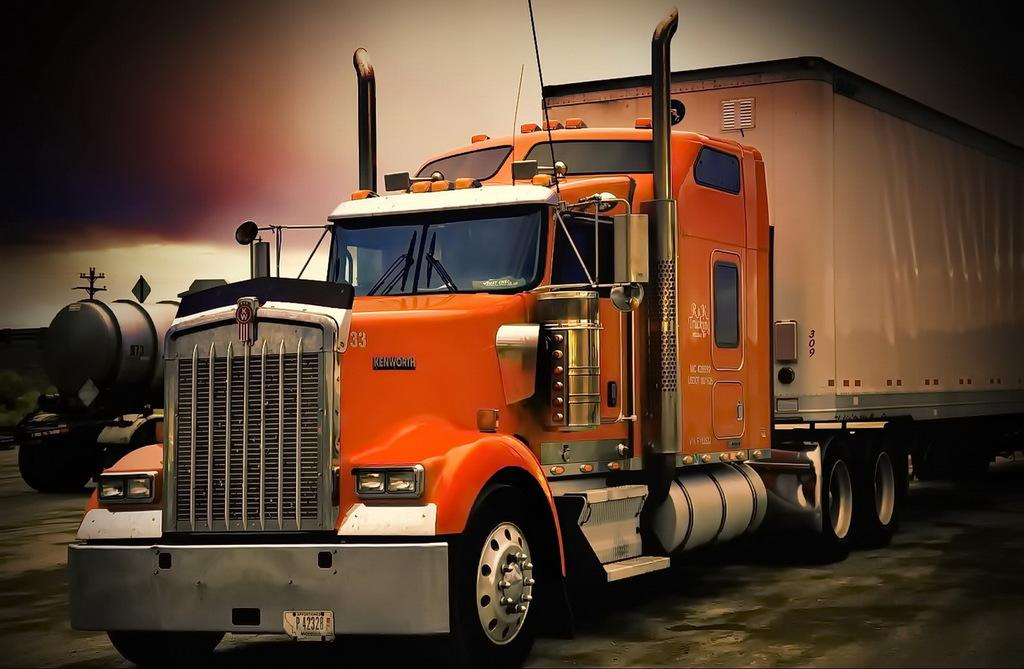How many vehicles can be seen in the image? There are two vehicles in the image. Where are the vehicles located? The vehicles are on a path in the image. What else is visible in the image besides the vehicles? There is a pole visible in the image. What can be seen in the background of the image? The sky is visible in the image. What type of roof can be seen on the vehicles in the image? There is no roof visible on the vehicles in the image, as they are likely open-air vehicles like bicycles or motorcycles. Is there a notebook present in the image? There is no notebook visible in the image. 